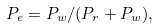Convert formula to latex. <formula><loc_0><loc_0><loc_500><loc_500>P _ { e } = P _ { w } / ( P _ { r } + P _ { w } ) ,</formula> 